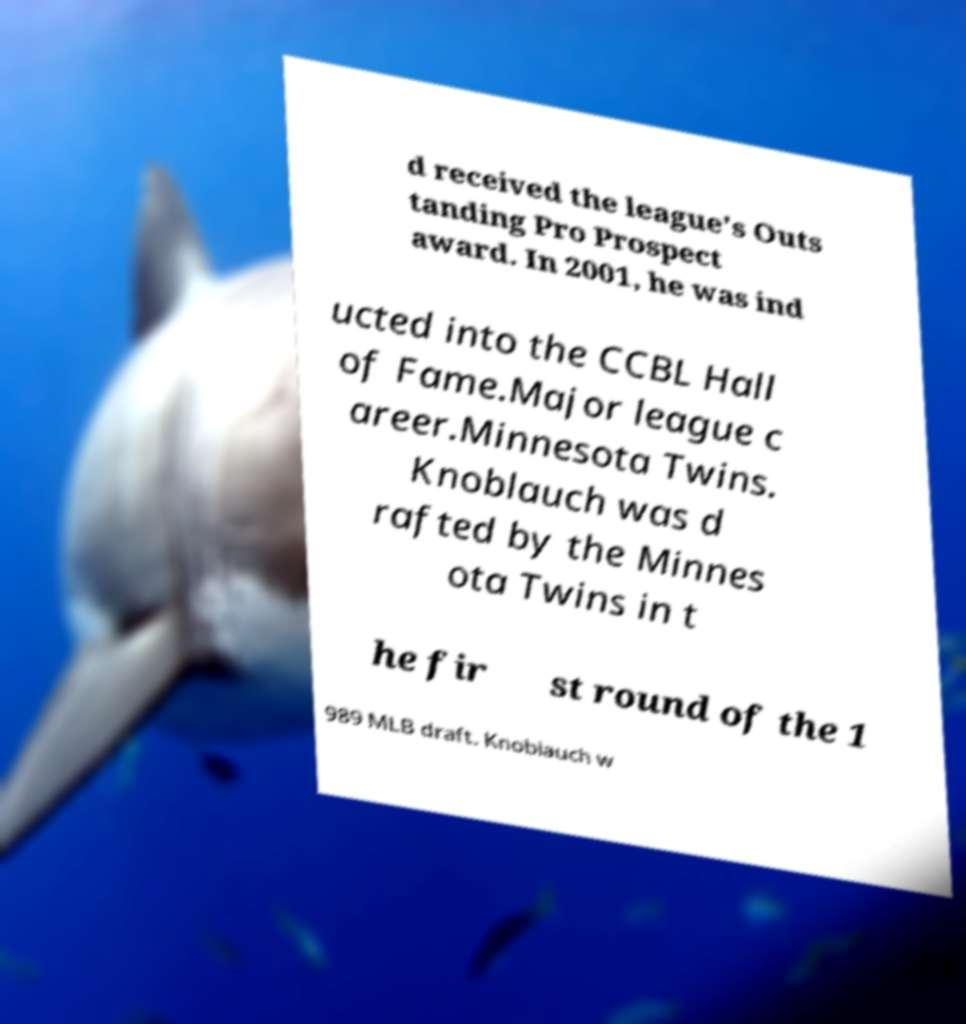Please identify and transcribe the text found in this image. d received the league's Outs tanding Pro Prospect award. In 2001, he was ind ucted into the CCBL Hall of Fame.Major league c areer.Minnesota Twins. Knoblauch was d rafted by the Minnes ota Twins in t he fir st round of the 1 989 MLB draft. Knoblauch w 